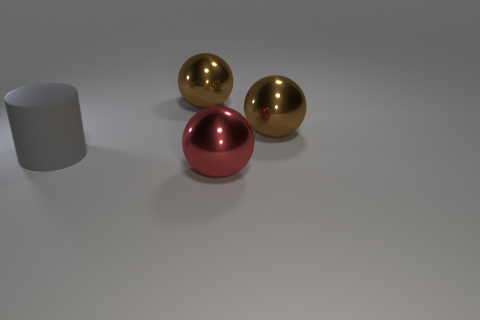What is the lighting condition in the scene? The lighting in the scene appears to be diffused, with a soft shadow cast underneath and to the right of the objects. This suggests that there might be a single light source located to the top left of the frame that is not directly visible in the image. Is there anything that indicates the spheres might be in motion or stationary? The spheres are casting soft but consistent shadows directly to their right, suggesting that they are stationary at the moment. There's no blur or other indications in the image that would imply motion. 